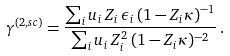<formula> <loc_0><loc_0><loc_500><loc_500>\gamma ^ { ( 2 , s c ) } = \frac { \sum _ { i } u _ { i } \, Z _ { i } \, \epsilon _ { i } \, ( 1 - Z _ { i } \kappa ) ^ { - 1 } } { \sum _ { i } u _ { i } \, Z _ { i } ^ { 2 } \, ( 1 - Z _ { i } \kappa ) ^ { - 2 } } \, .</formula> 